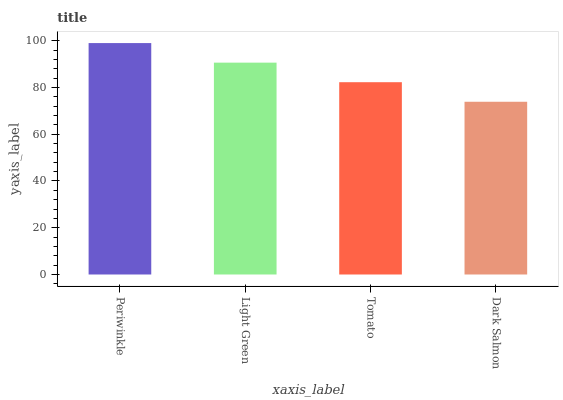Is Dark Salmon the minimum?
Answer yes or no. Yes. Is Periwinkle the maximum?
Answer yes or no. Yes. Is Light Green the minimum?
Answer yes or no. No. Is Light Green the maximum?
Answer yes or no. No. Is Periwinkle greater than Light Green?
Answer yes or no. Yes. Is Light Green less than Periwinkle?
Answer yes or no. Yes. Is Light Green greater than Periwinkle?
Answer yes or no. No. Is Periwinkle less than Light Green?
Answer yes or no. No. Is Light Green the high median?
Answer yes or no. Yes. Is Tomato the low median?
Answer yes or no. Yes. Is Dark Salmon the high median?
Answer yes or no. No. Is Dark Salmon the low median?
Answer yes or no. No. 